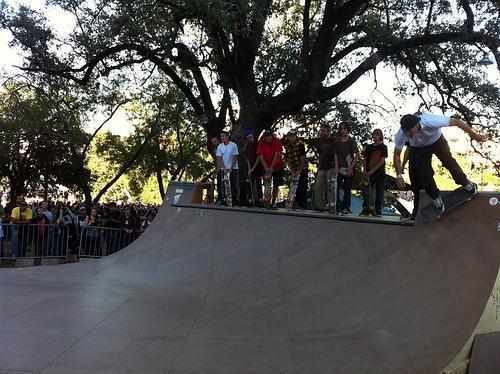How many people are actively skateboarding?
Give a very brief answer. 1. 